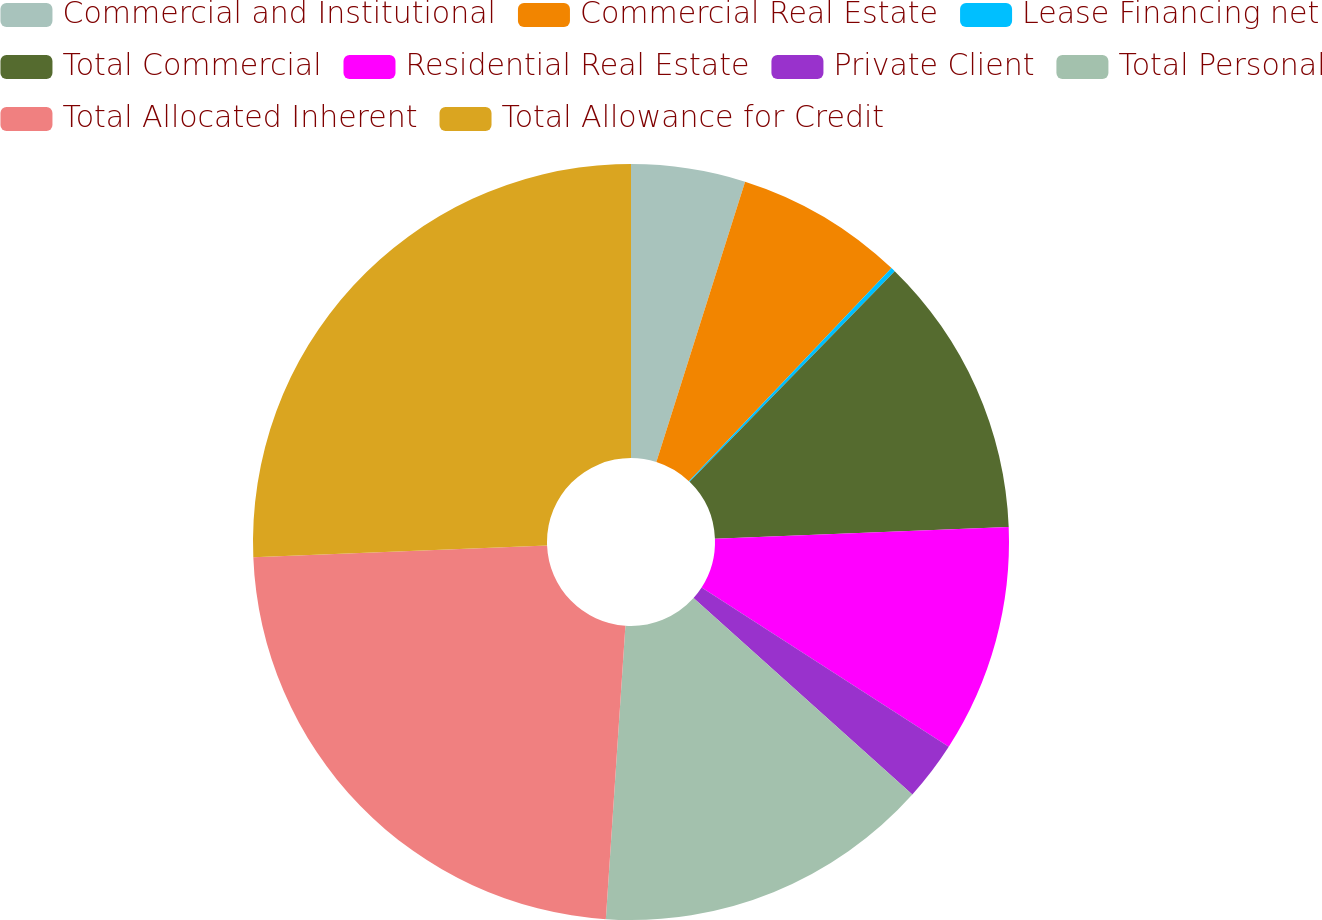Convert chart. <chart><loc_0><loc_0><loc_500><loc_500><pie_chart><fcel>Commercial and Institutional<fcel>Commercial Real Estate<fcel>Lease Financing net<fcel>Total Commercial<fcel>Residential Real Estate<fcel>Private Client<fcel>Total Personal<fcel>Total Allocated Inherent<fcel>Total Allowance for Credit<nl><fcel>4.88%<fcel>7.22%<fcel>0.19%<fcel>12.08%<fcel>9.74%<fcel>2.53%<fcel>14.42%<fcel>23.3%<fcel>25.64%<nl></chart> 